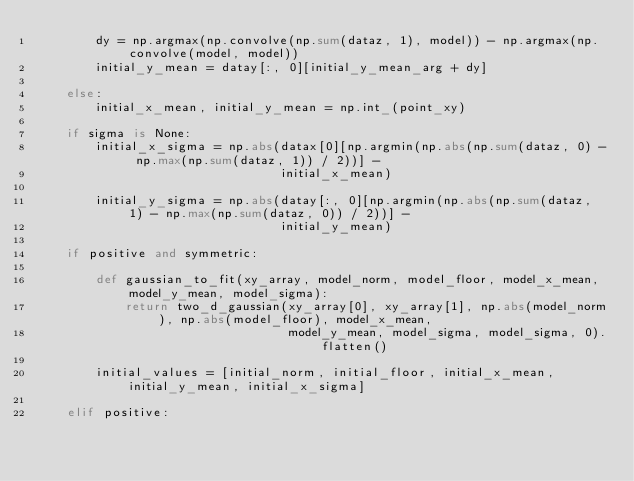<code> <loc_0><loc_0><loc_500><loc_500><_Python_>        dy = np.argmax(np.convolve(np.sum(dataz, 1), model)) - np.argmax(np.convolve(model, model))
        initial_y_mean = datay[:, 0][initial_y_mean_arg + dy]

    else:
        initial_x_mean, initial_y_mean = np.int_(point_xy)

    if sigma is None:
        initial_x_sigma = np.abs(datax[0][np.argmin(np.abs(np.sum(dataz, 0) - np.max(np.sum(dataz, 1)) / 2))] -
                                 initial_x_mean)

        initial_y_sigma = np.abs(datay[:, 0][np.argmin(np.abs(np.sum(dataz, 1) - np.max(np.sum(dataz, 0)) / 2))] -
                                 initial_y_mean)

    if positive and symmetric:

        def gaussian_to_fit(xy_array, model_norm, model_floor, model_x_mean, model_y_mean, model_sigma):
            return two_d_gaussian(xy_array[0], xy_array[1], np.abs(model_norm), np.abs(model_floor), model_x_mean,
                                  model_y_mean, model_sigma, model_sigma, 0).flatten()

        initial_values = [initial_norm, initial_floor, initial_x_mean, initial_y_mean, initial_x_sigma]

    elif positive:
</code> 